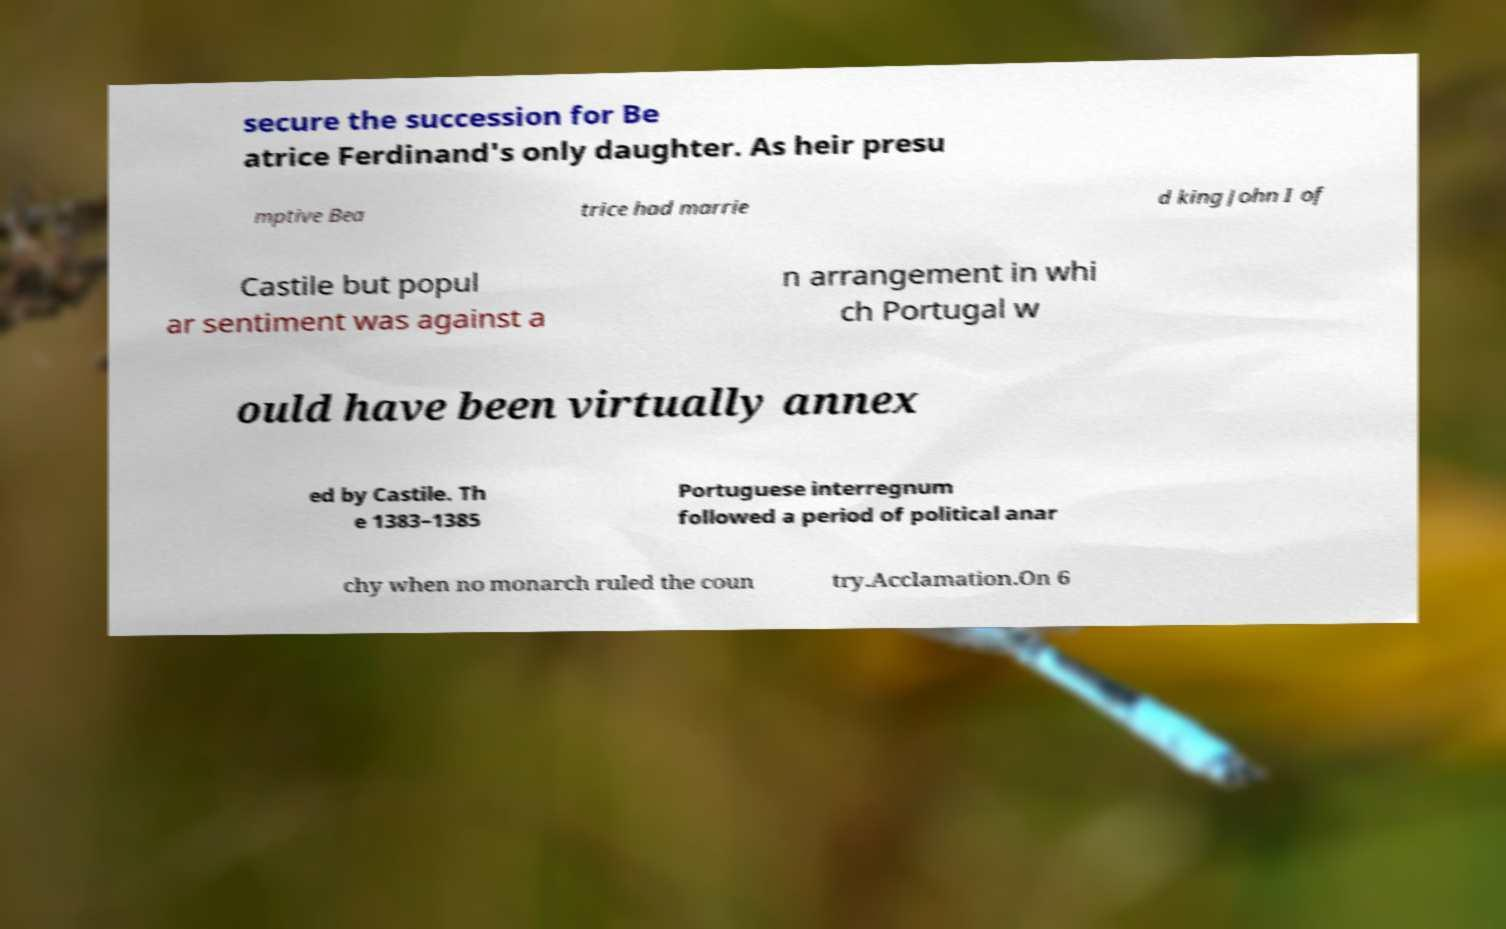There's text embedded in this image that I need extracted. Can you transcribe it verbatim? secure the succession for Be atrice Ferdinand's only daughter. As heir presu mptive Bea trice had marrie d king John I of Castile but popul ar sentiment was against a n arrangement in whi ch Portugal w ould have been virtually annex ed by Castile. Th e 1383–1385 Portuguese interregnum followed a period of political anar chy when no monarch ruled the coun try.Acclamation.On 6 